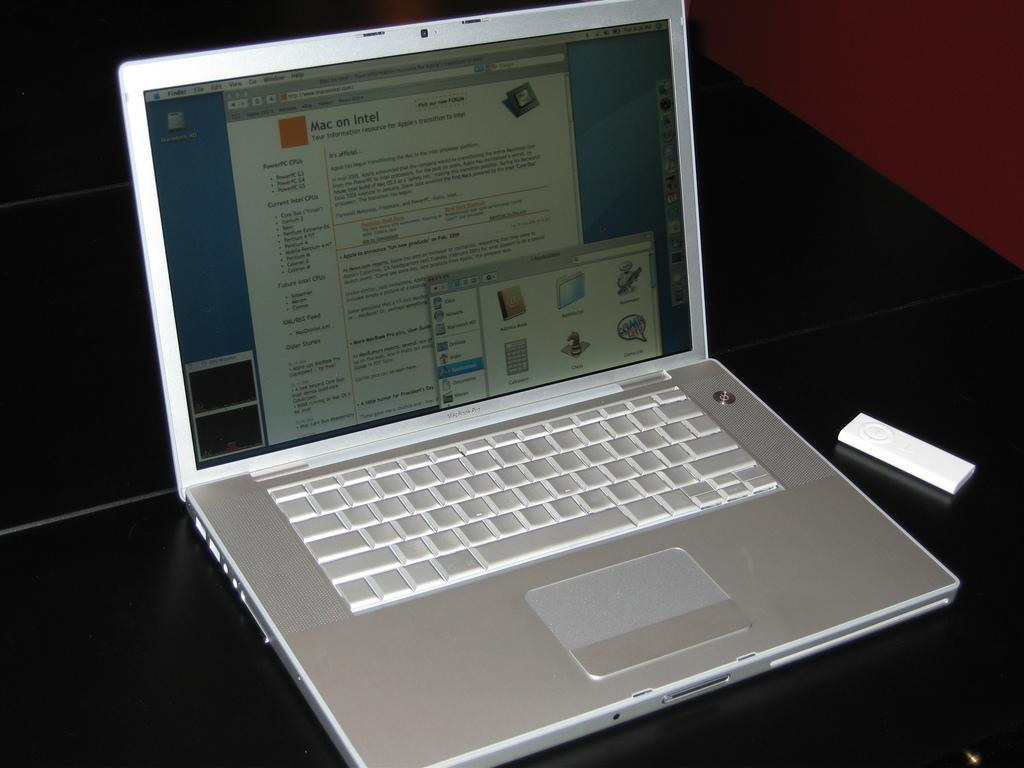Provide a one-sentence caption for the provided image. a silver macbook pro with an open page that says 'mac on intel'. 